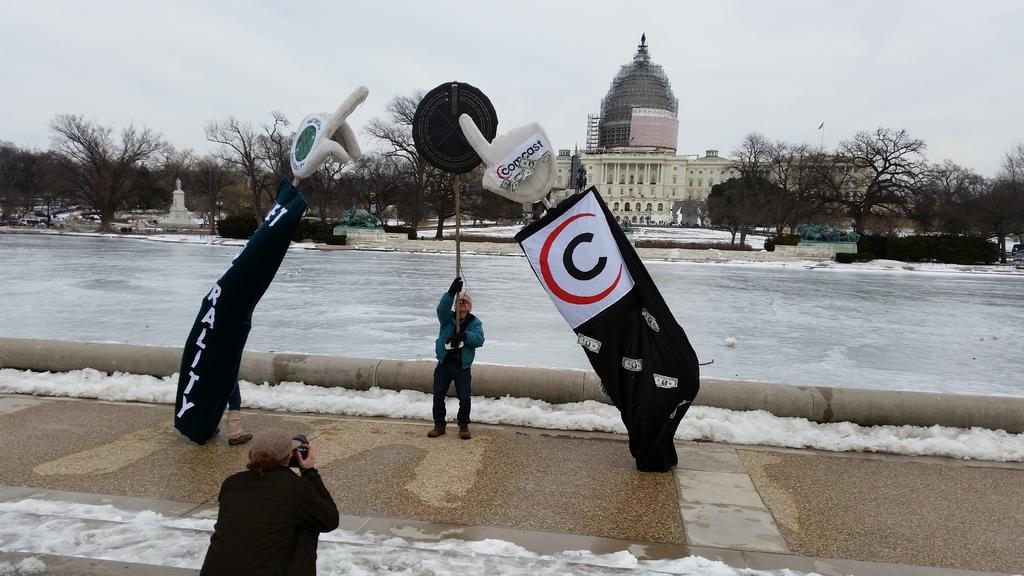Can you describe this image briefly? This image consists of a woman wearing green jacket is holding a stick. At the bottom, there is a person capturing the image. In the background, there is water along with a building. And there are many trees. 